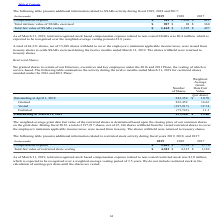According to Agilysys's financial document, How many shares were issued from treasury in 2019? 197,917 shares, net of 47,146 shares. The document states: "on the grant date. During fiscal 2019, a total of 197,917 shares, net of 47,146 shares withheld from the vested restricted shares to cover the employe..." Also, What were the number of outstanding shares at April 1, 2018? According to the financial document, 243,354. The relevant text states: "Outstanding at April 1, 2018 243,354 $ 10.78..." Also, What was the weighted average granted date fair value per share at April 1, 2018? According to the financial document, $10.78. The relevant text states: "Outstanding at April 1, 2018 243,354 $ 10.78..." Also, can you calculate: What was the difference between the granted shares and outstanding shares as at April 1, 2018? Based on the calculation: 265,452 - 243,354, the result is 22098. This is based on the information: "Granted 265,452 14.66 Outstanding at April 1, 2018 243,354 $ 10.78..." The key data points involved are: 243,354, 265,452. Also, can you calculate: What is the total  Weighted-Average Grant-Date Fair Value for Outstanding at April 1, 2018? Based on the calculation:  243,354* 10.78, the result is 2623356.12. This is based on the information: "Outstanding at April 1, 2018 243,354 $ 10.78 Outstanding at April 1, 2018 243,354 $ 10.78..." The key data points involved are: 10.78, 243,354. Also, can you calculate: What was the difference between the vested and granted Weighted-Average Grant-Date Fair Value? Based on the calculation: 14.66-12.74, the result is 1.92. This is based on the information: "Granted 265,452 14.66 Vested (197,917) 12.74..." The key data points involved are: 12.74, 14.66. 